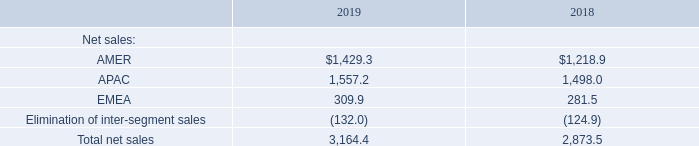A discussion of net sales by reportable segment is presented below for the indicated fiscal years (in millions):
AMER. Net sales for fiscal 2019 in the AMER segment increased $210.4 million, or 17.3%, as compared to fiscal 2018. The increase in net sales was driven by a $181.7 million increase in production ramps of new products for existing customers, a $13.5 million increase in production ramps for new customers and overall net increased customer end-market demand. The increase was partially offset by a $16.4 million decrease for end-of-life products and a $6.0 million reduction due to disengagements with customers.
APAC. Net sales for fiscal 2019 in the APAC segment increased $59.2 million, or 4.0%, as compared to fiscal 2018. The increase in net sales was driven by an $87.3 million increase in production ramps of new products for existing customers and a $58.1 million increase in production ramps for new customers. The increase was partially offset by a $28.4 million reduction due to a disengagement with a customer, a $7.3 million decrease for end-of-life products and overall net decreased customer end-market demand.
EMEA. Net sales for fiscal 2019 in the EMEA segment increased $28.4 million, or 10.1%, as compared to fiscal 2018. The increase in net sales was the result of a $20.2 million increase in production ramps of new products for existing customers, a $4.2 million increase in production ramps for new customers and overall net increased customer end-market demand. The increase was partially offset by a $6.2 million reduction due to a disengagement with a customer.
Which years does the table provide information for net sales by reportable segment? 2019, 2018. What was the net sales from AMER in 2018?
Answer scale should be: million. 1,218.9. What was the net sales from EMEA in 2019?
Answer scale should be: million. 309.9. How many years did net sales from APAC exceed $1,500 million? 2019
Answer: 1. What was the difference in net sales in 2018 between AMER and EMEA regions?
Answer scale should be: million. 1,218.9-281.5
Answer: 937.4. What was the percentage change in the Elimination of inter-segment sales between 2018 and 2019?
Answer scale should be: percent. (-132.0-(-124.9))/-124.9
Answer: 5.68. 